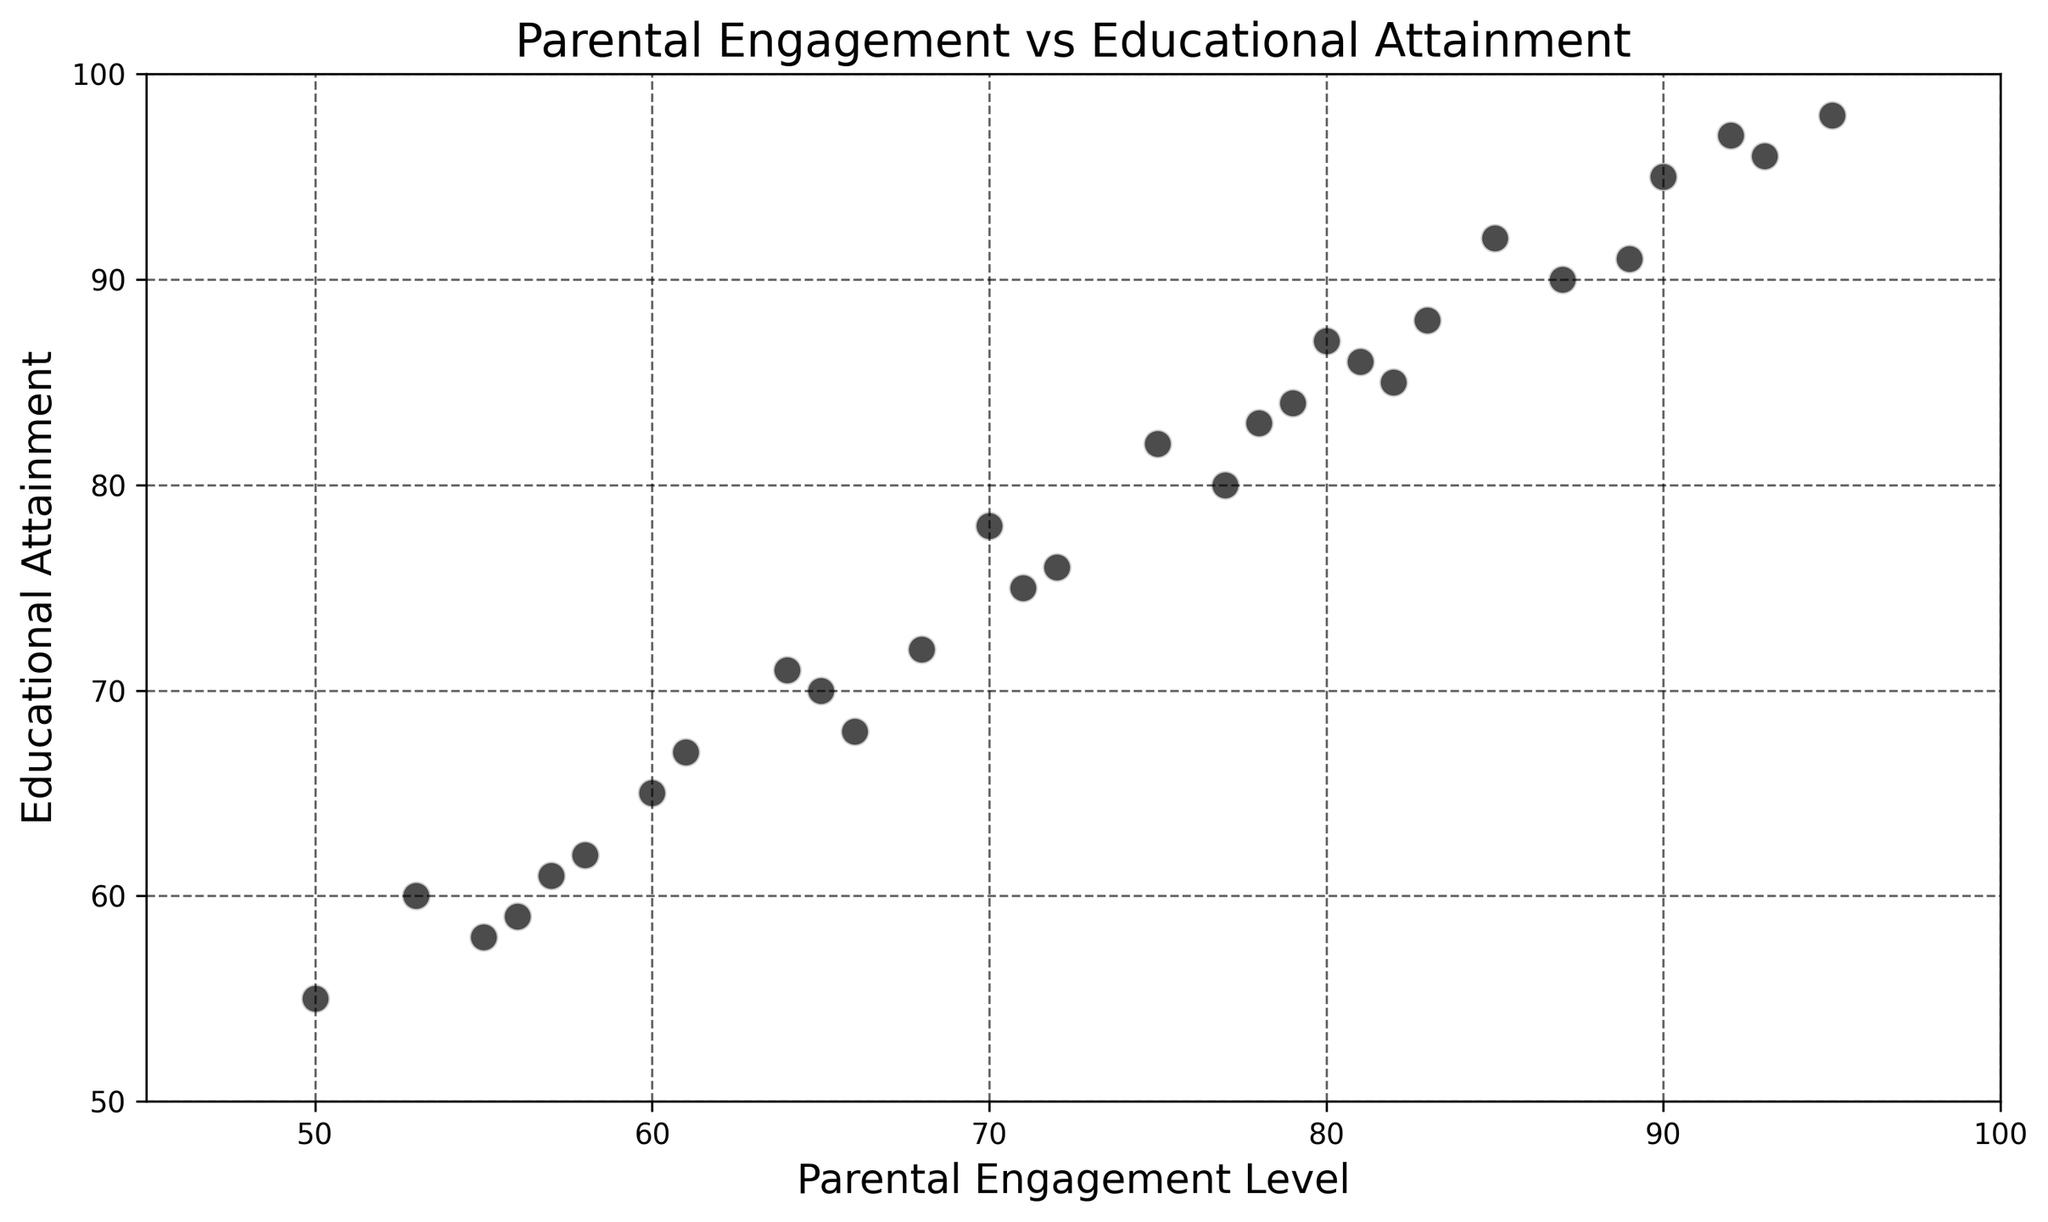Which data point has the highest educational attainment? Identify the point with the highest value on the y-axis (Educational Attainment). The highest point is at Educational Attainment = 98.
Answer: 98 Which student ID has the lowest parental engagement level? Locate the point with the lowest value on the x-axis (Parental Engagement Level). The point with the lowest x-value is at Parental Engagement Level = 50, corresponding to Student ID = 7.
Answer: 7 What is the average parental engagement level for the students shown in the plot? Sum all the parental engagement levels and divide by the total number of students (30). Total engagement level = 70 + 85 + 60 + 90 + 55 + 80 + 50 + 95 + 65 + 77 + 82 + 68 + 53 + 92 + 75 + 87 + 61 + 78 + 58 + 93 + 64 + 72 + 56 + 89 + 83 + 66 + 79 + 81 + 57 + 71 = 1971. Average = 1971 / 30.
Answer: 65.7 Which student's educational attainment is equal to the sum of their parental engagement level and 8? Identify the student where Educational Attainment = Parental Engagement Level + 8. For Student ID = 1, 70 + 8 = 78.
Answer: 1 How many students have a parental engagement level greater than 75 and educational attainment greater than 85? Count the points that are both to the right of x=75 and above y=85. Students meeting these conditions are Student IDs = 2, 6, 8, 11, 14, 16, 20, 24, 25, 28.
Answer: 10 